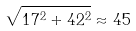<formula> <loc_0><loc_0><loc_500><loc_500>\sqrt { 1 7 ^ { 2 } + 4 2 ^ { 2 } } \approx 4 5</formula> 